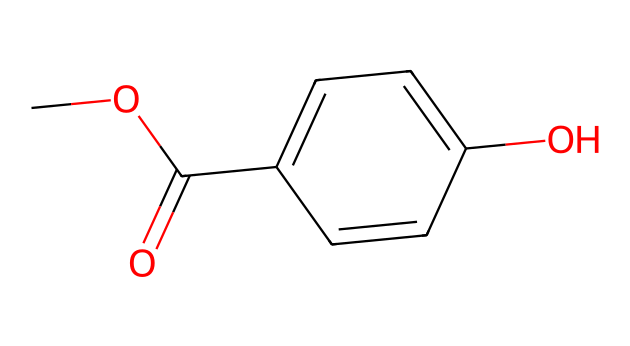What is the molecular formula of methylparaben? To find the molecular formula, we count the number of each type of atom in the structure. The chemical has 9 carbon (C) atoms, 10 hydrogen (H) atoms, and 3 oxygen (O) atoms. Combining these gives the molecular formula: C9H10O3.
Answer: C9H10O3 How many rings are present in the structure of methylparaben? Observing the structure, we see that there is one six-membered aromatic ring indicated in the formula, represented by the 'C1=CC=C(C=C1)' part. Thus, there is one ring present.
Answer: 1 What type of functional group is present in methylparaben? Looking at the structure, we can see an ester functional group indicated by 'C(=O)O' as well as a hydroxyl (-OH) group. Methylparaben is a methyl ester of p-hydroxybenzoic acid.
Answer: ester What is the degree of unsaturation in methylparaben? The degree of unsaturation is calculated from the formula considering how many rings and double bonds are present. The formula for degree of unsaturation is (2C + 2 + N - H - X)/2. Here, C=9, H=10, which gives a degree of unsaturation of 3, accounting for the aromatic ring and double bond(s).
Answer: 3 How many hydroxyl groups are found in methylparaben? The structure shows a -OH group directly attached to the aromatic ring, indicating that there is one hydroxyl group in the chemical structure of methylparaben.
Answer: 1 